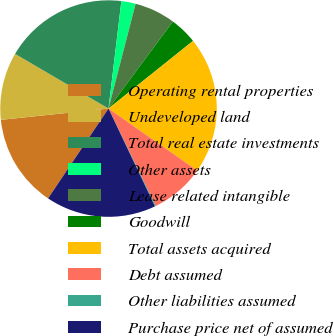Convert chart. <chart><loc_0><loc_0><loc_500><loc_500><pie_chart><fcel>Operating rental properties<fcel>Undeveloped land<fcel>Total real estate investments<fcel>Other assets<fcel>Lease related intangible<fcel>Goodwill<fcel>Total assets acquired<fcel>Debt assumed<fcel>Other liabilities assumed<fcel>Purchase price net of assumed<nl><fcel>13.91%<fcel>10.09%<fcel>18.47%<fcel>2.13%<fcel>6.11%<fcel>4.12%<fcel>20.46%<fcel>8.1%<fcel>0.13%<fcel>16.48%<nl></chart> 